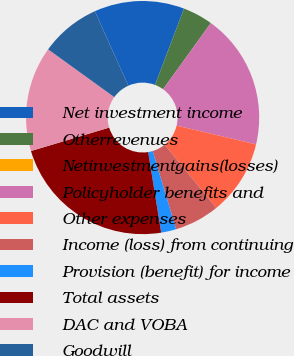Convert chart. <chart><loc_0><loc_0><loc_500><loc_500><pie_chart><fcel>Net investment income<fcel>Otherrevenues<fcel>Netinvestmentgains(losses)<fcel>Policyholder benefits and<fcel>Other expenses<fcel>Income (loss) from continuing<fcel>Provision (benefit) for income<fcel>Total assets<fcel>DAC and VOBA<fcel>Goodwill<nl><fcel>12.5%<fcel>4.17%<fcel>0.0%<fcel>18.75%<fcel>10.42%<fcel>6.25%<fcel>2.09%<fcel>22.91%<fcel>14.58%<fcel>8.33%<nl></chart> 